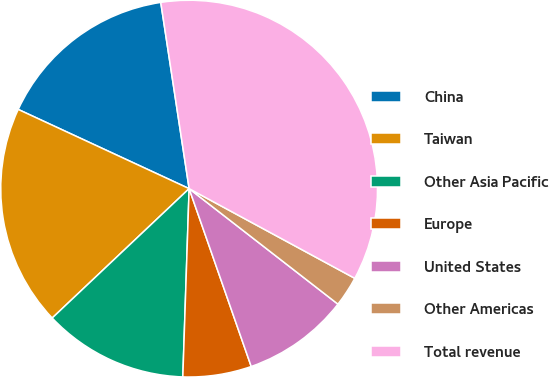Convert chart. <chart><loc_0><loc_0><loc_500><loc_500><pie_chart><fcel>China<fcel>Taiwan<fcel>Other Asia Pacific<fcel>Europe<fcel>United States<fcel>Other Americas<fcel>Total revenue<nl><fcel>15.69%<fcel>18.96%<fcel>12.42%<fcel>5.88%<fcel>9.15%<fcel>2.61%<fcel>35.31%<nl></chart> 